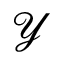Convert formula to latex. <formula><loc_0><loc_0><loc_500><loc_500>\mathcal { Y }</formula> 